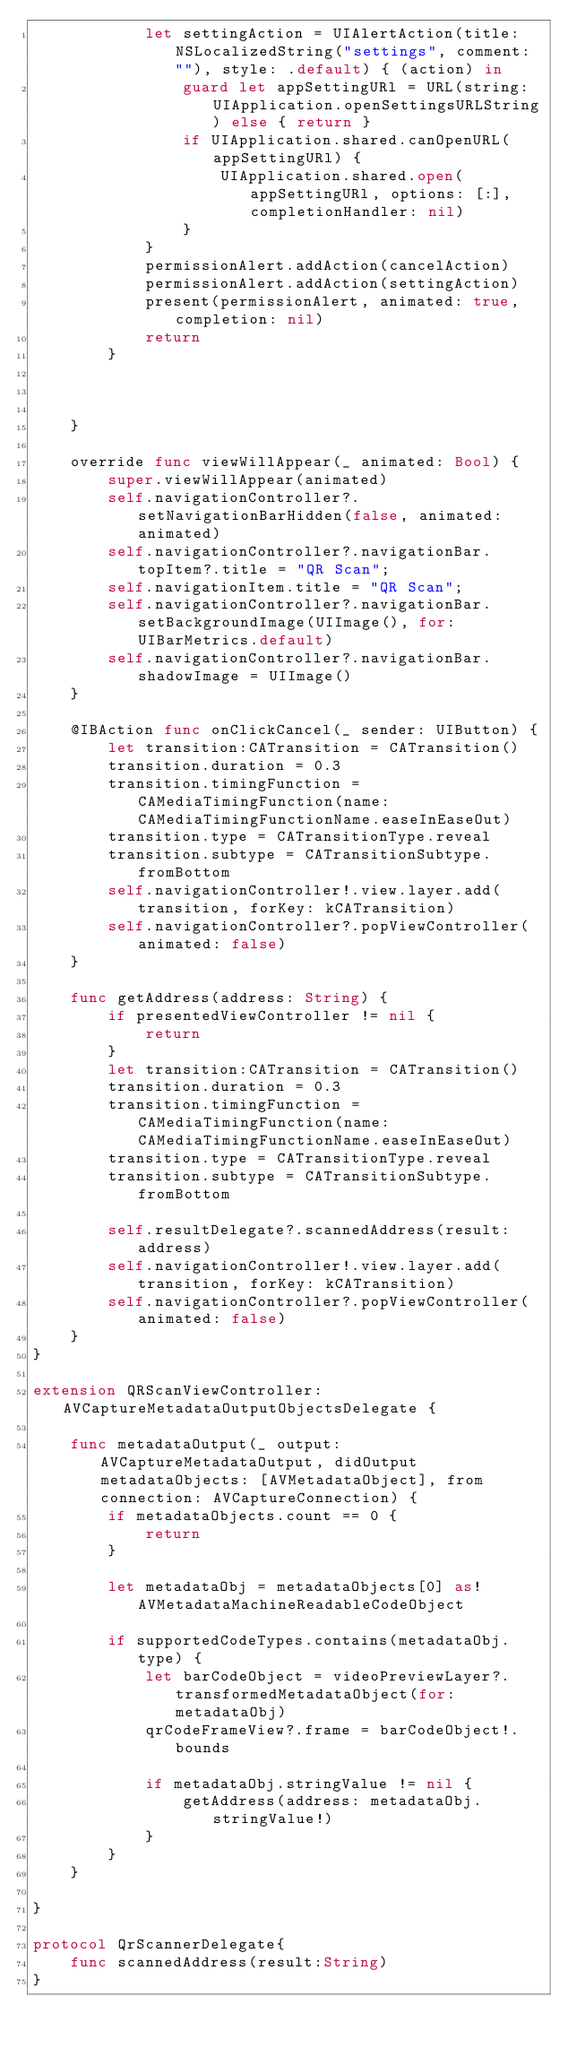<code> <loc_0><loc_0><loc_500><loc_500><_Swift_>            let settingAction = UIAlertAction(title: NSLocalizedString("settings", comment: ""), style: .default) { (action) in
                guard let appSettingURl = URL(string: UIApplication.openSettingsURLString) else { return }
                if UIApplication.shared.canOpenURL(appSettingURl) {
                    UIApplication.shared.open(appSettingURl, options: [:], completionHandler: nil)
                }
            }
            permissionAlert.addAction(cancelAction)
            permissionAlert.addAction(settingAction)
            present(permissionAlert, animated: true, completion: nil)
            return
        }
        
        
        
    }
    
    override func viewWillAppear(_ animated: Bool) {
        super.viewWillAppear(animated)
        self.navigationController?.setNavigationBarHidden(false, animated: animated)
        self.navigationController?.navigationBar.topItem?.title = "QR Scan";
        self.navigationItem.title = "QR Scan";
        self.navigationController?.navigationBar.setBackgroundImage(UIImage(), for: UIBarMetrics.default)
        self.navigationController?.navigationBar.shadowImage = UIImage()
    }

    @IBAction func onClickCancel(_ sender: UIButton) {
        let transition:CATransition = CATransition()
        transition.duration = 0.3
        transition.timingFunction = CAMediaTimingFunction(name: CAMediaTimingFunctionName.easeInEaseOut)
        transition.type = CATransitionType.reveal
        transition.subtype = CATransitionSubtype.fromBottom
        self.navigationController!.view.layer.add(transition, forKey: kCATransition)
        self.navigationController?.popViewController(animated: false)
    }
    
    func getAddress(address: String) {
        if presentedViewController != nil {
            return
        }
        let transition:CATransition = CATransition()
        transition.duration = 0.3
        transition.timingFunction = CAMediaTimingFunction(name: CAMediaTimingFunctionName.easeInEaseOut)
        transition.type = CATransitionType.reveal
        transition.subtype = CATransitionSubtype.fromBottom
        
        self.resultDelegate?.scannedAddress(result: address)
        self.navigationController!.view.layer.add(transition, forKey: kCATransition)
        self.navigationController?.popViewController(animated: false)
    }
}

extension QRScanViewController: AVCaptureMetadataOutputObjectsDelegate {
    
    func metadataOutput(_ output: AVCaptureMetadataOutput, didOutput metadataObjects: [AVMetadataObject], from connection: AVCaptureConnection) {
        if metadataObjects.count == 0 {
            return
        }
        
        let metadataObj = metadataObjects[0] as! AVMetadataMachineReadableCodeObject
        
        if supportedCodeTypes.contains(metadataObj.type) {
            let barCodeObject = videoPreviewLayer?.transformedMetadataObject(for: metadataObj)
            qrCodeFrameView?.frame = barCodeObject!.bounds

            if metadataObj.stringValue != nil {
                getAddress(address: metadataObj.stringValue!)
            }
        }
    }
    
}

protocol QrScannerDelegate{
    func scannedAddress(result:String)
}

</code> 